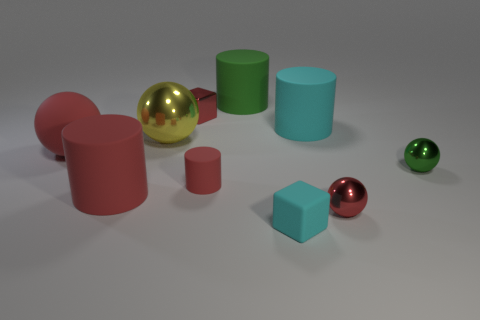Subtract 1 spheres. How many spheres are left? 3 Subtract all cylinders. How many objects are left? 6 Subtract 0 gray cylinders. How many objects are left? 10 Subtract all large metallic spheres. Subtract all tiny shiny blocks. How many objects are left? 8 Add 5 large green rubber objects. How many large green rubber objects are left? 6 Add 6 small red shiny things. How many small red shiny things exist? 8 